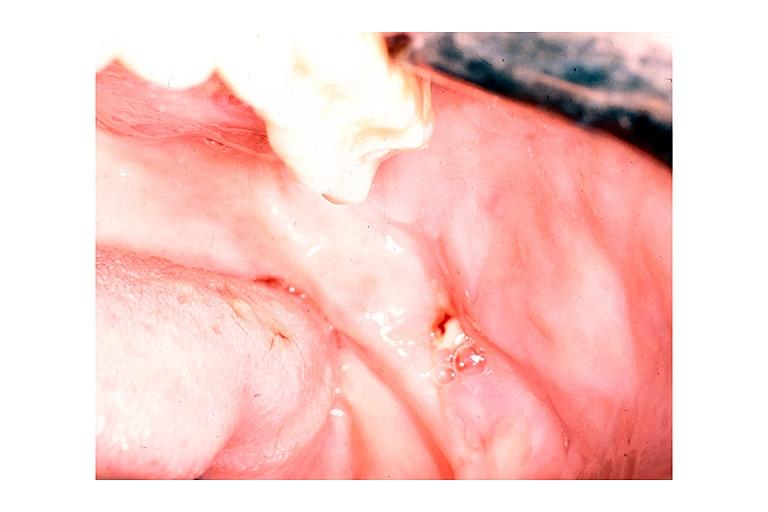does this image show chronic osteomyelitis?
Answer the question using a single word or phrase. Yes 